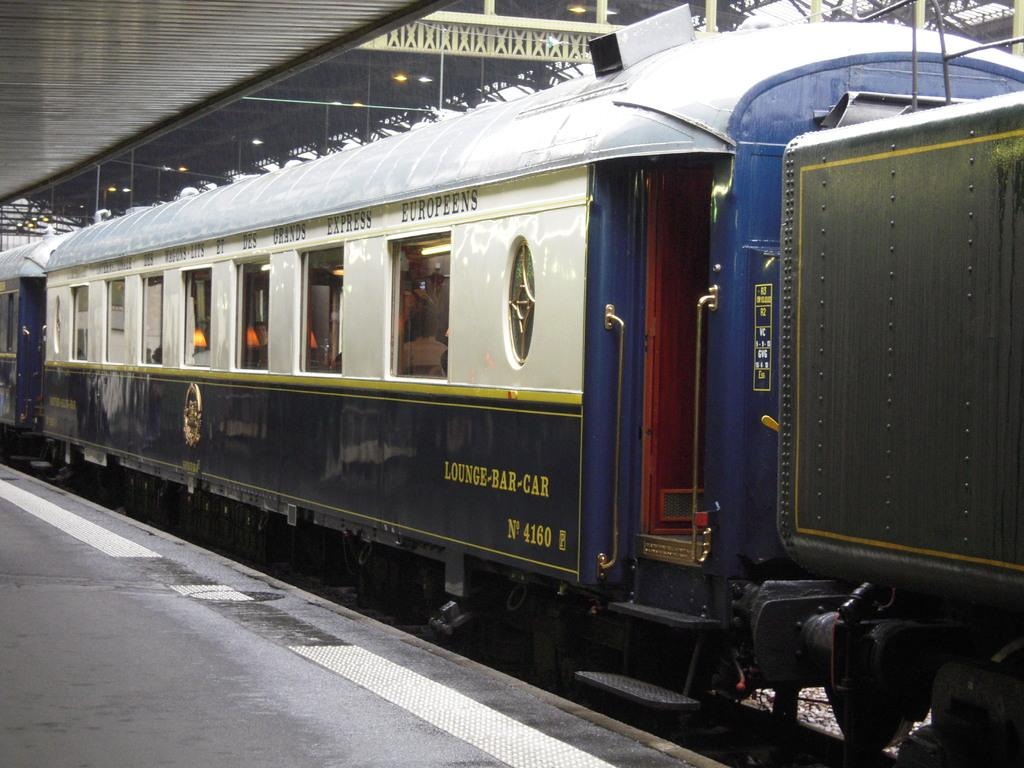Provide a one-sentence caption for the provided image. The lounge-bar car of a train sitting in a station. 